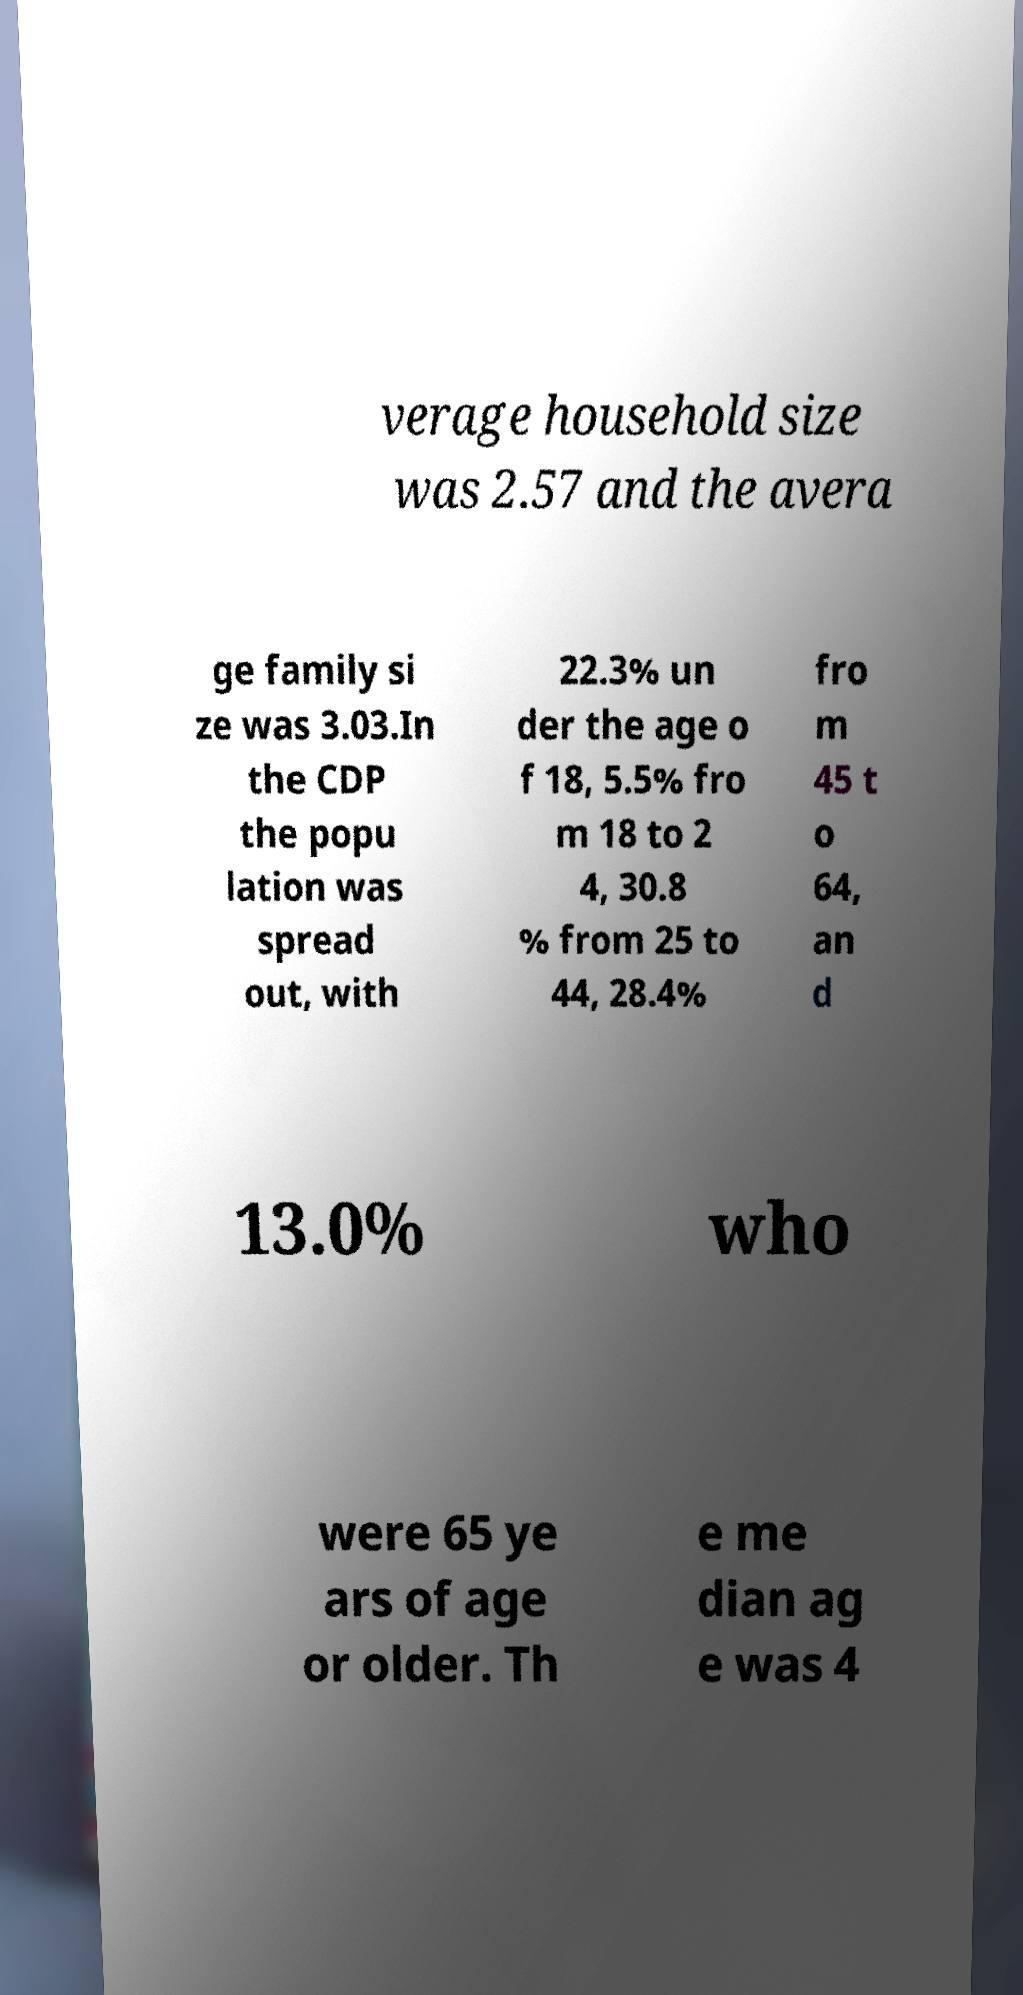What messages or text are displayed in this image? I need them in a readable, typed format. verage household size was 2.57 and the avera ge family si ze was 3.03.In the CDP the popu lation was spread out, with 22.3% un der the age o f 18, 5.5% fro m 18 to 2 4, 30.8 % from 25 to 44, 28.4% fro m 45 t o 64, an d 13.0% who were 65 ye ars of age or older. Th e me dian ag e was 4 